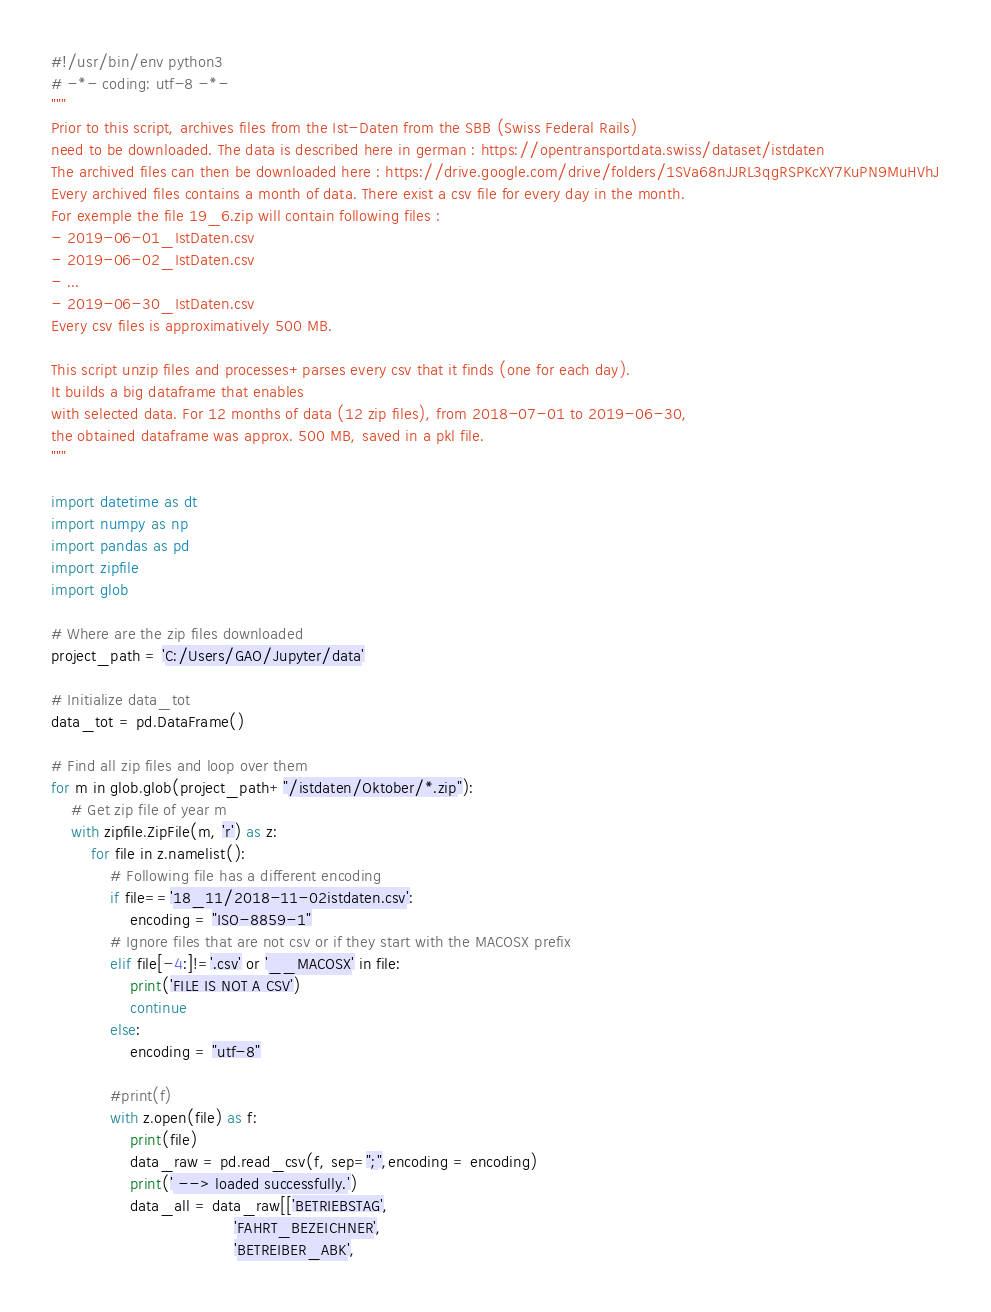<code> <loc_0><loc_0><loc_500><loc_500><_Python_>#!/usr/bin/env python3
# -*- coding: utf-8 -*-
"""
Prior to this script, archives files from the Ist-Daten from the SBB (Swiss Federal Rails)
need to be downloaded. The data is described here in german : https://opentransportdata.swiss/dataset/istdaten
The archived files can then be downloaded here : https://drive.google.com/drive/folders/1SVa68nJJRL3qgRSPKcXY7KuPN9MuHVhJ
Every archived files contains a month of data. There exist a csv file for every day in the month.
For exemple the file 19_6.zip will contain following files : 
- 2019-06-01_IstDaten.csv
- 2019-06-02_IstDaten.csv
- ...
- 2019-06-30_IstDaten.csv
Every csv files is approximatively 500 MB.

This script unzip files and processes+parses every csv that it finds (one for each day). 
It builds a big dataframe that enables
with selected data. For 12 months of data (12 zip files), from 2018-07-01 to 2019-06-30,
the obtained dataframe was approx. 500 MB, saved in a pkl file.
"""

import datetime as dt
import numpy as np
import pandas as pd
import zipfile
import glob

# Where are the zip files downloaded
project_path = 'C:/Users/GAO/Jupyter/data'

# Initialize data_tot
data_tot = pd.DataFrame()

# Find all zip files and loop over them
for m in glob.glob(project_path+"/istdaten/Oktober/*.zip"):
    # Get zip file of year m
    with zipfile.ZipFile(m, 'r') as z:
        for file in z.namelist():
            # Following file has a different encoding
            if file=='18_11/2018-11-02istdaten.csv':
                encoding = "ISO-8859-1"
            # Ignore files that are not csv or if they start with the MACOSX prefix
            elif file[-4:]!='.csv' or '__MACOSX' in file:
                print('FILE IS NOT A CSV')
                continue
            else:
                encoding = "utf-8"
                
            #print(f)
            with z.open(file) as f:
                print(file)
                data_raw = pd.read_csv(f, sep=";",encoding = encoding)
                print(' --> loaded successfully.')
                data_all = data_raw[['BETRIEBSTAG',
                                     'FAHRT_BEZEICHNER',
                                     'BETREIBER_ABK',</code> 